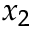Convert formula to latex. <formula><loc_0><loc_0><loc_500><loc_500>x _ { 2 }</formula> 